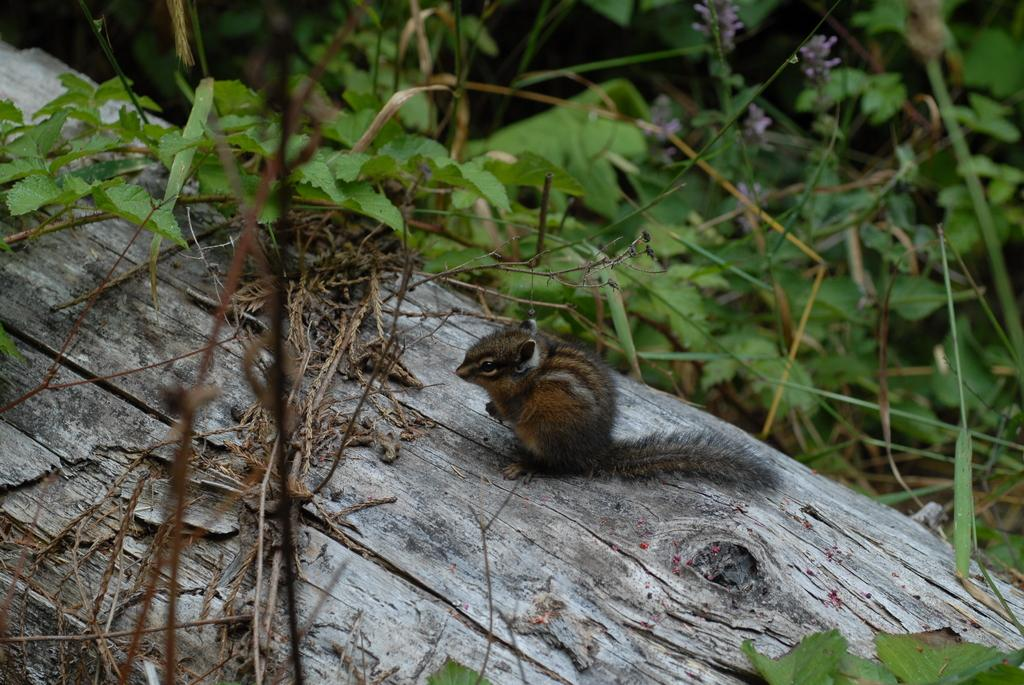What is the main object in the center of the image? There is a piece of wood in the center of the image. What is on top of the piece of wood? There is a squirrel on the wood. What can be seen in the background of the image? There are plants visible in the background of the image. What type of dinner is being served on the wood in the image? There is no dinner being served in the image; it features a squirrel on a piece of wood with plants in the background. 